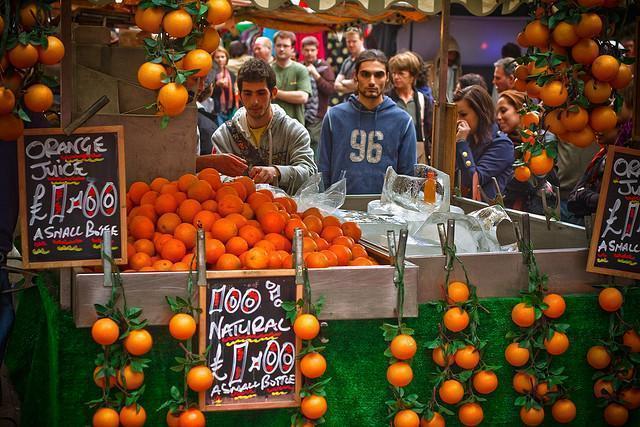What are they waiting in line for?
Choose the right answer from the provided options to respond to the question.
Options: Buy juice, pick oranges, exit, sell juice. Buy juice. 